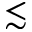<formula> <loc_0><loc_0><loc_500><loc_500>\lesssim</formula> 